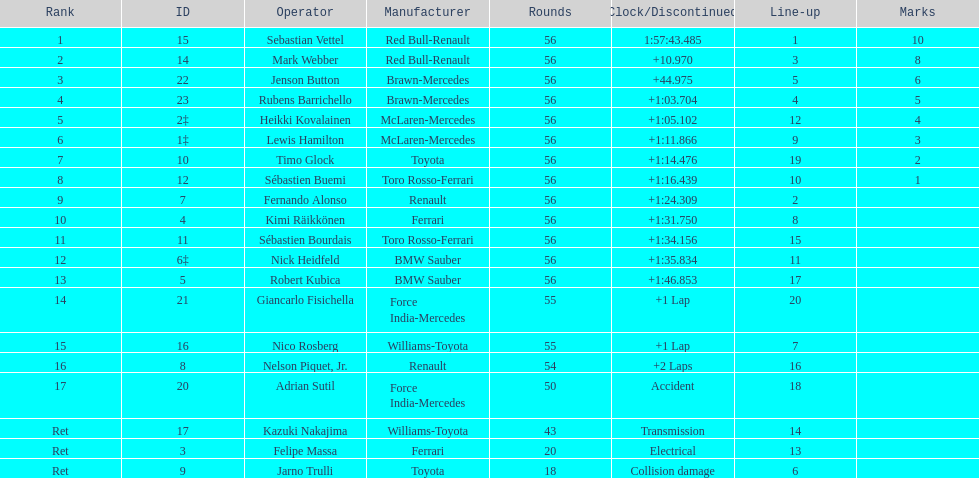How many drivers did not finish 56 laps? 7. 